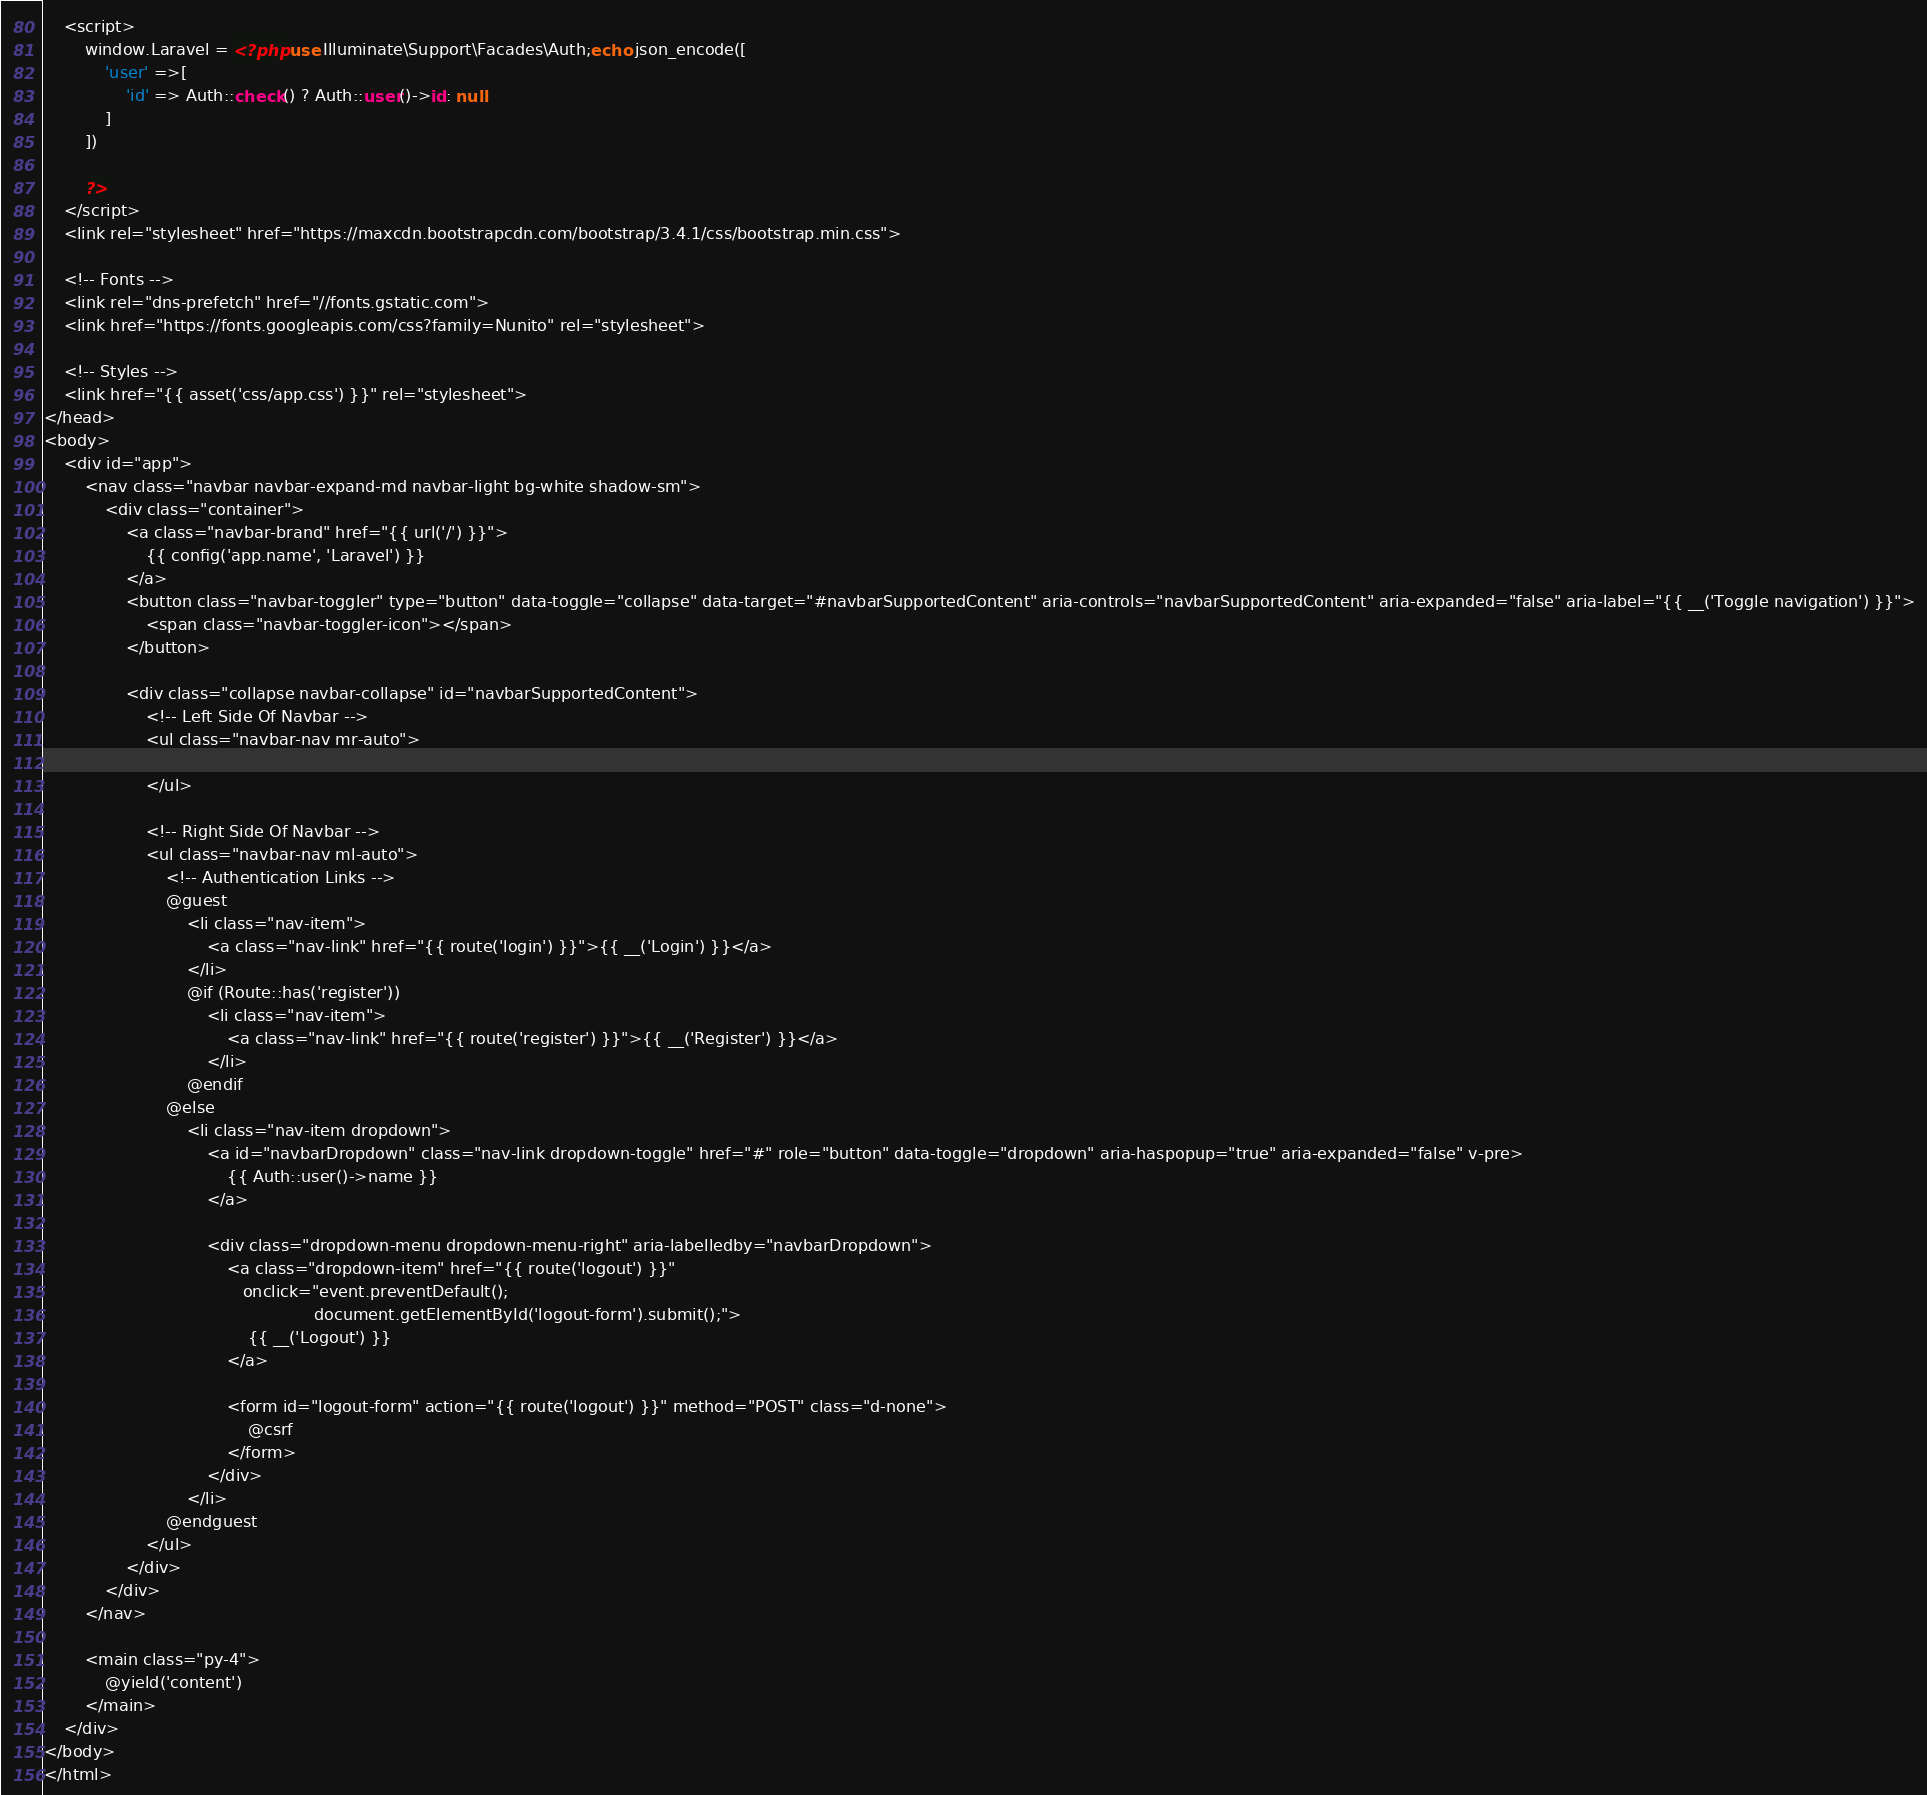<code> <loc_0><loc_0><loc_500><loc_500><_PHP_>    <script>
        window.Laravel = <?php use Illuminate\Support\Facades\Auth;echo json_encode([
            'user' =>[
                'id' => Auth::check() ? Auth::user()->id: null
            ]
        ])

        ?>
    </script>
    <link rel="stylesheet" href="https://maxcdn.bootstrapcdn.com/bootstrap/3.4.1/css/bootstrap.min.css">

    <!-- Fonts -->
    <link rel="dns-prefetch" href="//fonts.gstatic.com">
    <link href="https://fonts.googleapis.com/css?family=Nunito" rel="stylesheet">

    <!-- Styles -->
    <link href="{{ asset('css/app.css') }}" rel="stylesheet">
</head>
<body>
    <div id="app">
        <nav class="navbar navbar-expand-md navbar-light bg-white shadow-sm">
            <div class="container">
                <a class="navbar-brand" href="{{ url('/') }}">
                    {{ config('app.name', 'Laravel') }}
                </a>
                <button class="navbar-toggler" type="button" data-toggle="collapse" data-target="#navbarSupportedContent" aria-controls="navbarSupportedContent" aria-expanded="false" aria-label="{{ __('Toggle navigation') }}">
                    <span class="navbar-toggler-icon"></span>
                </button>

                <div class="collapse navbar-collapse" id="navbarSupportedContent">
                    <!-- Left Side Of Navbar -->
                    <ul class="navbar-nav mr-auto">

                    </ul>

                    <!-- Right Side Of Navbar -->
                    <ul class="navbar-nav ml-auto">
                        <!-- Authentication Links -->
                        @guest
                            <li class="nav-item">
                                <a class="nav-link" href="{{ route('login') }}">{{ __('Login') }}</a>
                            </li>
                            @if (Route::has('register'))
                                <li class="nav-item">
                                    <a class="nav-link" href="{{ route('register') }}">{{ __('Register') }}</a>
                                </li>
                            @endif
                        @else
                            <li class="nav-item dropdown">
                                <a id="navbarDropdown" class="nav-link dropdown-toggle" href="#" role="button" data-toggle="dropdown" aria-haspopup="true" aria-expanded="false" v-pre>
                                    {{ Auth::user()->name }}
                                </a>

                                <div class="dropdown-menu dropdown-menu-right" aria-labelledby="navbarDropdown">
                                    <a class="dropdown-item" href="{{ route('logout') }}"
                                       onclick="event.preventDefault();
                                                     document.getElementById('logout-form').submit();">
                                        {{ __('Logout') }}
                                    </a>

                                    <form id="logout-form" action="{{ route('logout') }}" method="POST" class="d-none">
                                        @csrf
                                    </form>
                                </div>
                            </li>
                        @endguest
                    </ul>
                </div>
            </div>
        </nav>

        <main class="py-4">
            @yield('content')
        </main>
    </div>
</body>
</html>
</code> 